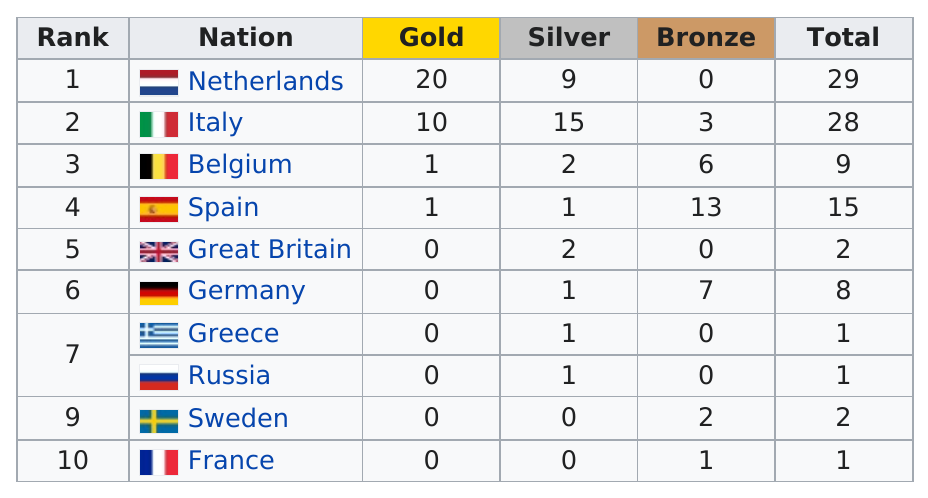Identify some key points in this picture. In the European Baseball Championship, Sweden has more medals than Russia, but Russia has a higher rank. Therefore, Sweden is the team that has more medals but is lower in rank compared to Russia in the European Baseball Championship. After Spain, the nation that earned the most total medals is Belgium. Spain is the only nation to have earned more than seven bronze medals. The Netherlands and Russia have both won zero European Baseball Championship medals of the bronze type. Spain is ranked first in terms of the number of bronze medals won. 